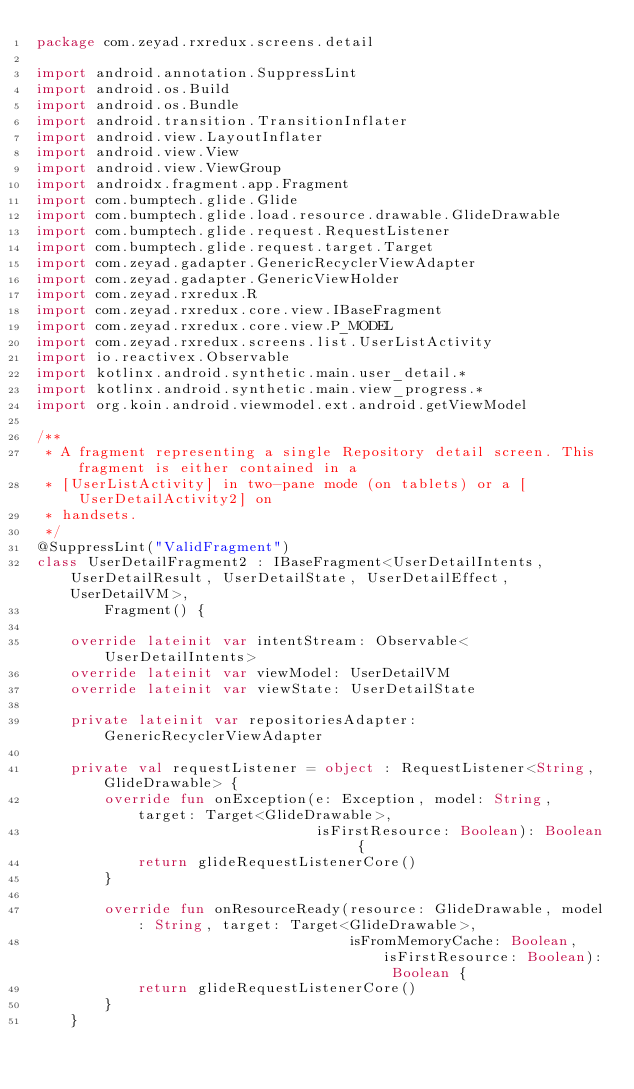<code> <loc_0><loc_0><loc_500><loc_500><_Kotlin_>package com.zeyad.rxredux.screens.detail

import android.annotation.SuppressLint
import android.os.Build
import android.os.Bundle
import android.transition.TransitionInflater
import android.view.LayoutInflater
import android.view.View
import android.view.ViewGroup
import androidx.fragment.app.Fragment
import com.bumptech.glide.Glide
import com.bumptech.glide.load.resource.drawable.GlideDrawable
import com.bumptech.glide.request.RequestListener
import com.bumptech.glide.request.target.Target
import com.zeyad.gadapter.GenericRecyclerViewAdapter
import com.zeyad.gadapter.GenericViewHolder
import com.zeyad.rxredux.R
import com.zeyad.rxredux.core.view.IBaseFragment
import com.zeyad.rxredux.core.view.P_MODEL
import com.zeyad.rxredux.screens.list.UserListActivity
import io.reactivex.Observable
import kotlinx.android.synthetic.main.user_detail.*
import kotlinx.android.synthetic.main.view_progress.*
import org.koin.android.viewmodel.ext.android.getViewModel

/**
 * A fragment representing a single Repository detail screen. This fragment is either contained in a
 * [UserListActivity] in two-pane mode (on tablets) or a [UserDetailActivity2] on
 * handsets.
 */
@SuppressLint("ValidFragment")
class UserDetailFragment2 : IBaseFragment<UserDetailIntents, UserDetailResult, UserDetailState, UserDetailEffect, UserDetailVM>,
        Fragment() {

    override lateinit var intentStream: Observable<UserDetailIntents>
    override lateinit var viewModel: UserDetailVM
    override lateinit var viewState: UserDetailState

    private lateinit var repositoriesAdapter: GenericRecyclerViewAdapter

    private val requestListener = object : RequestListener<String, GlideDrawable> {
        override fun onException(e: Exception, model: String, target: Target<GlideDrawable>,
                                 isFirstResource: Boolean): Boolean {
            return glideRequestListenerCore()
        }

        override fun onResourceReady(resource: GlideDrawable, model: String, target: Target<GlideDrawable>,
                                     isFromMemoryCache: Boolean, isFirstResource: Boolean): Boolean {
            return glideRequestListenerCore()
        }
    }
</code> 